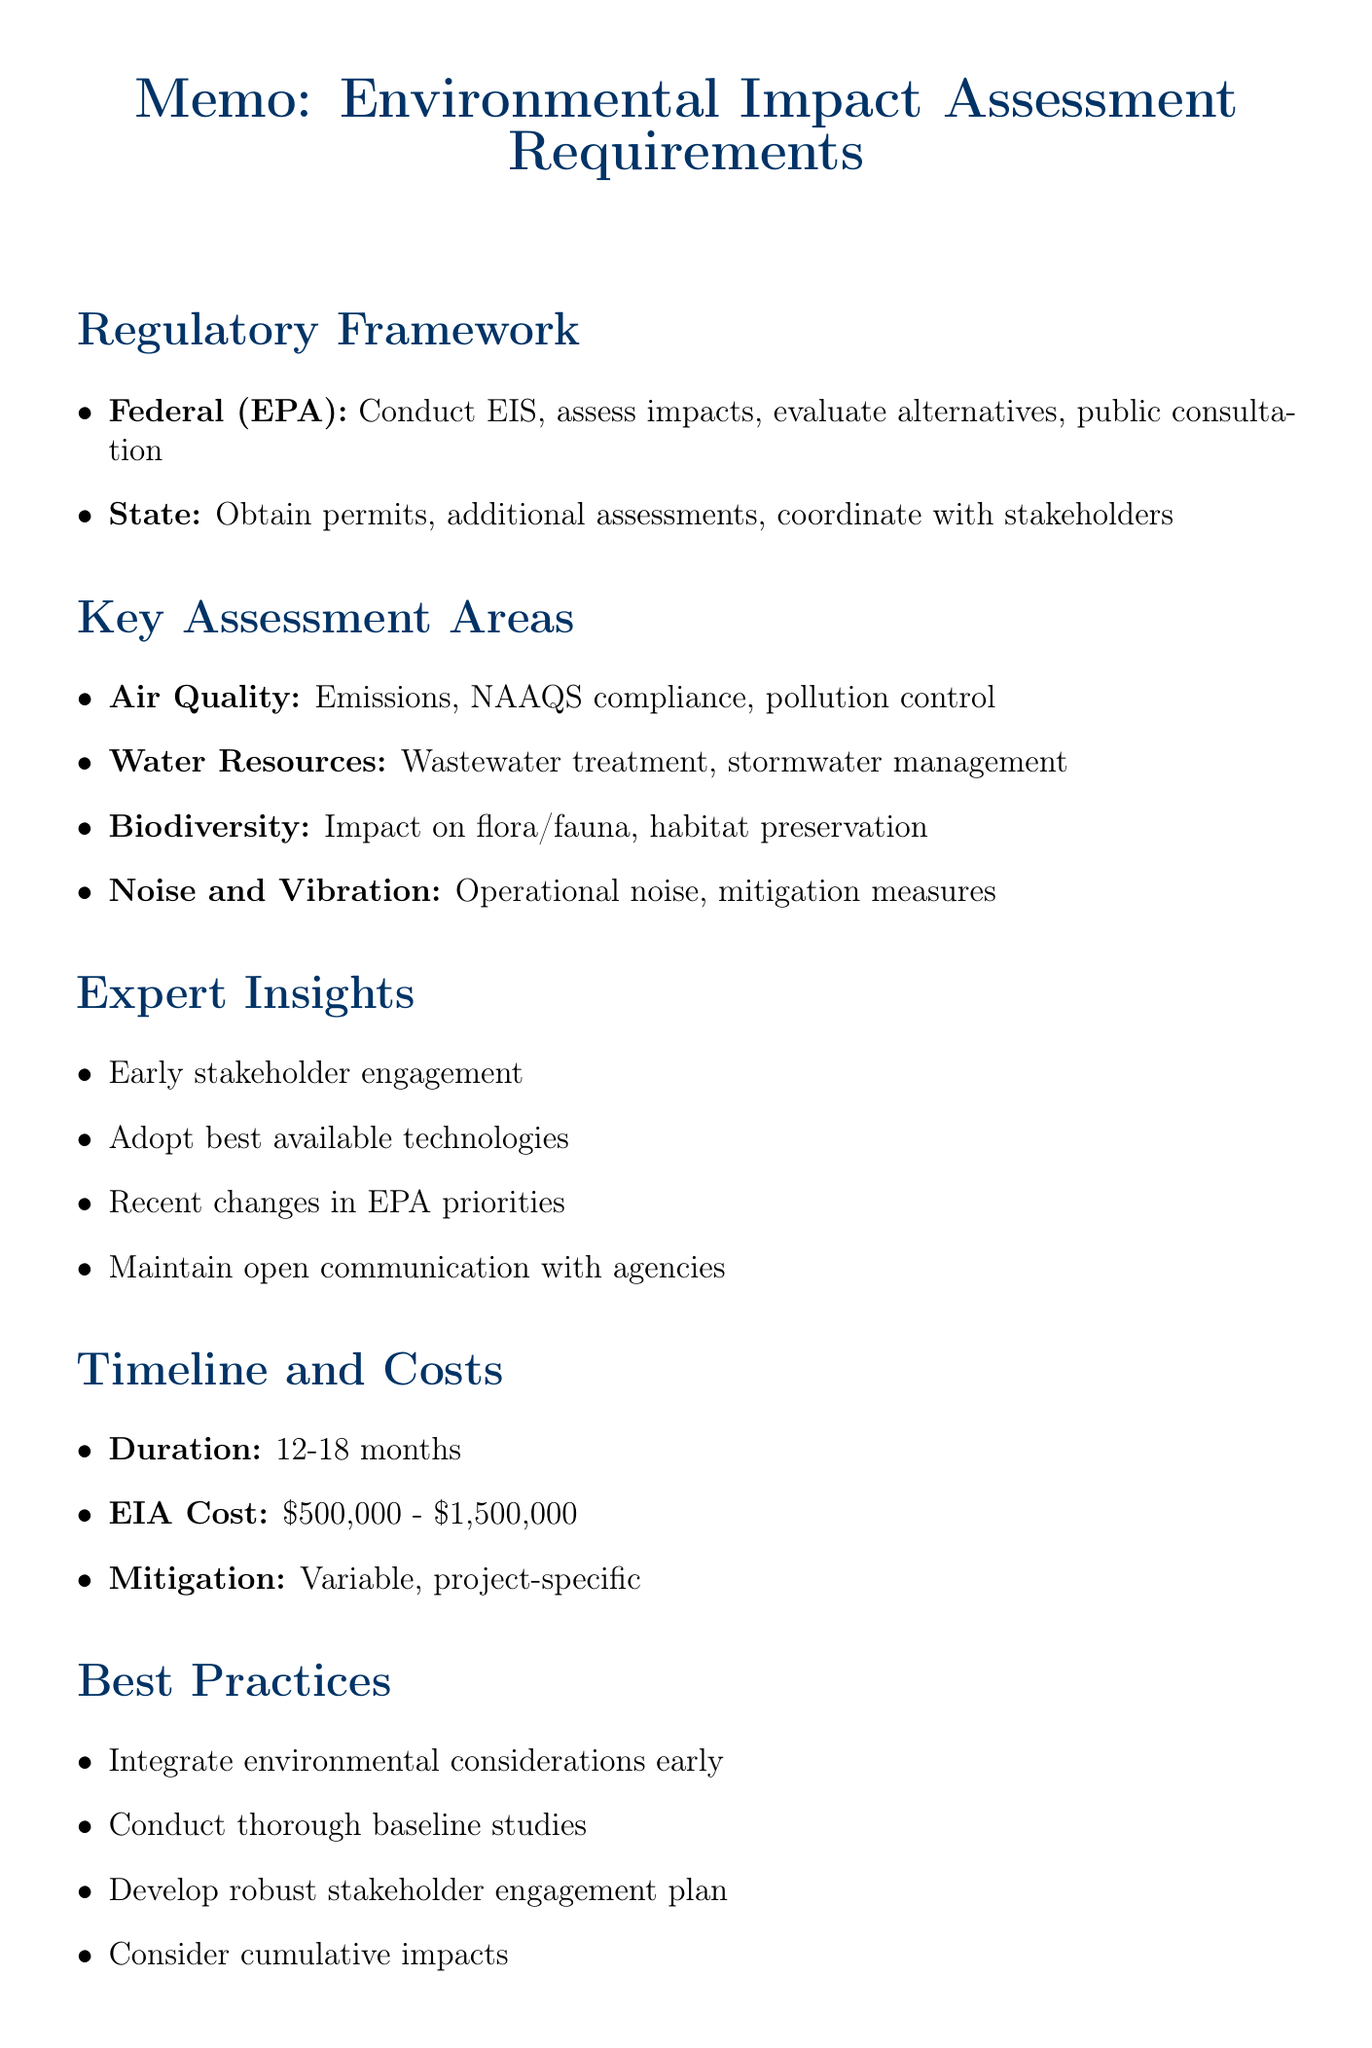What is the key federal regulation referred to in the memo? The key federal regulation mentioned is the "National Environmental Policy Act (NEPA)."
Answer: National Environmental Policy Act (NEPA) What is the estimated duration for the Environmental Impact Assessment process? The estimated duration is provided in the document as a range for the EIA process.
Answer: 12-18 months Who is the expert affiliated with EcoConsult Inc.? The document specifies the expert by name and their affiliation.
Answer: Dr. Emily Chen What area considers emissions from manufacturing processes? This area is highlighted under the key assessment areas in the memo.
Answer: Air Quality What are the estimated costs for the EIA process? The document lists a range for the estimated costs involved in the EIA process.
Answer: $500,000 - $1,500,000 What should be integrated early in the project design phase according to best practices? This is identified among the best practices in the document regarding project planning.
Answer: Environmental considerations What is one potential challenge mentioned in the memo? The document specifies several challenges, one of which is relevant to public sentiment.
Answer: Public opposition or NIMBY How long is the public comment period for the draft Environmental Impact Statement? The document provides a specific timeframe for this phase of the EIA process.
Answer: 45-60 days What is the first step listed under next steps in the memo? The next steps section outlines initial actions to take following the memo’s guidance.
Answer: Engage an experienced environmental consulting firm 